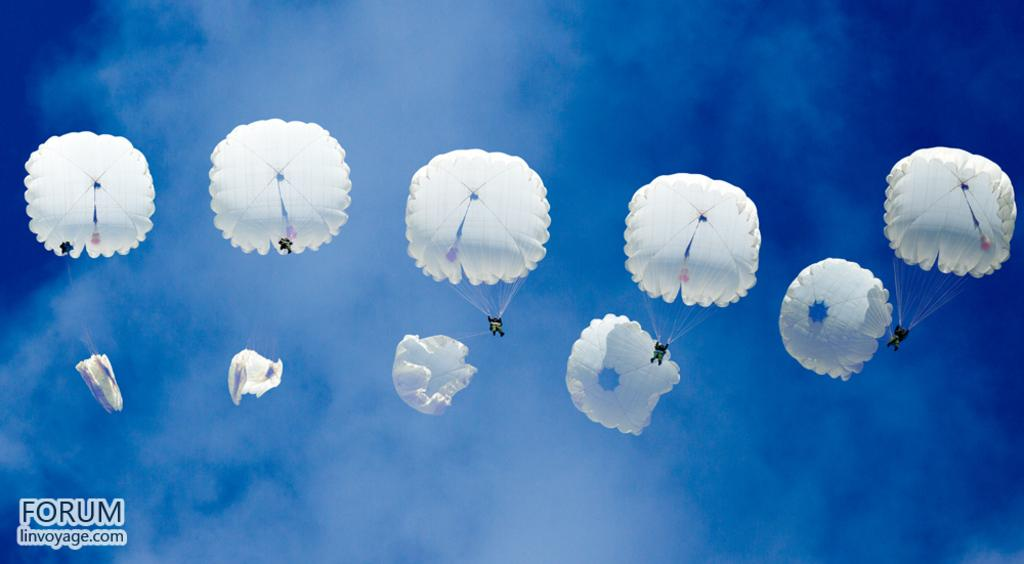What activity are the people in the image engaged in? The people in the image are paragliding in the sky. Can you describe any text that is visible in the image? There is some text in the bottom left corner of the image. What type of dirt can be seen on the paragliders' shoes in the image? There is no dirt visible on the paragliders' shoes in the image, as they are in the sky and not in contact with the ground. 